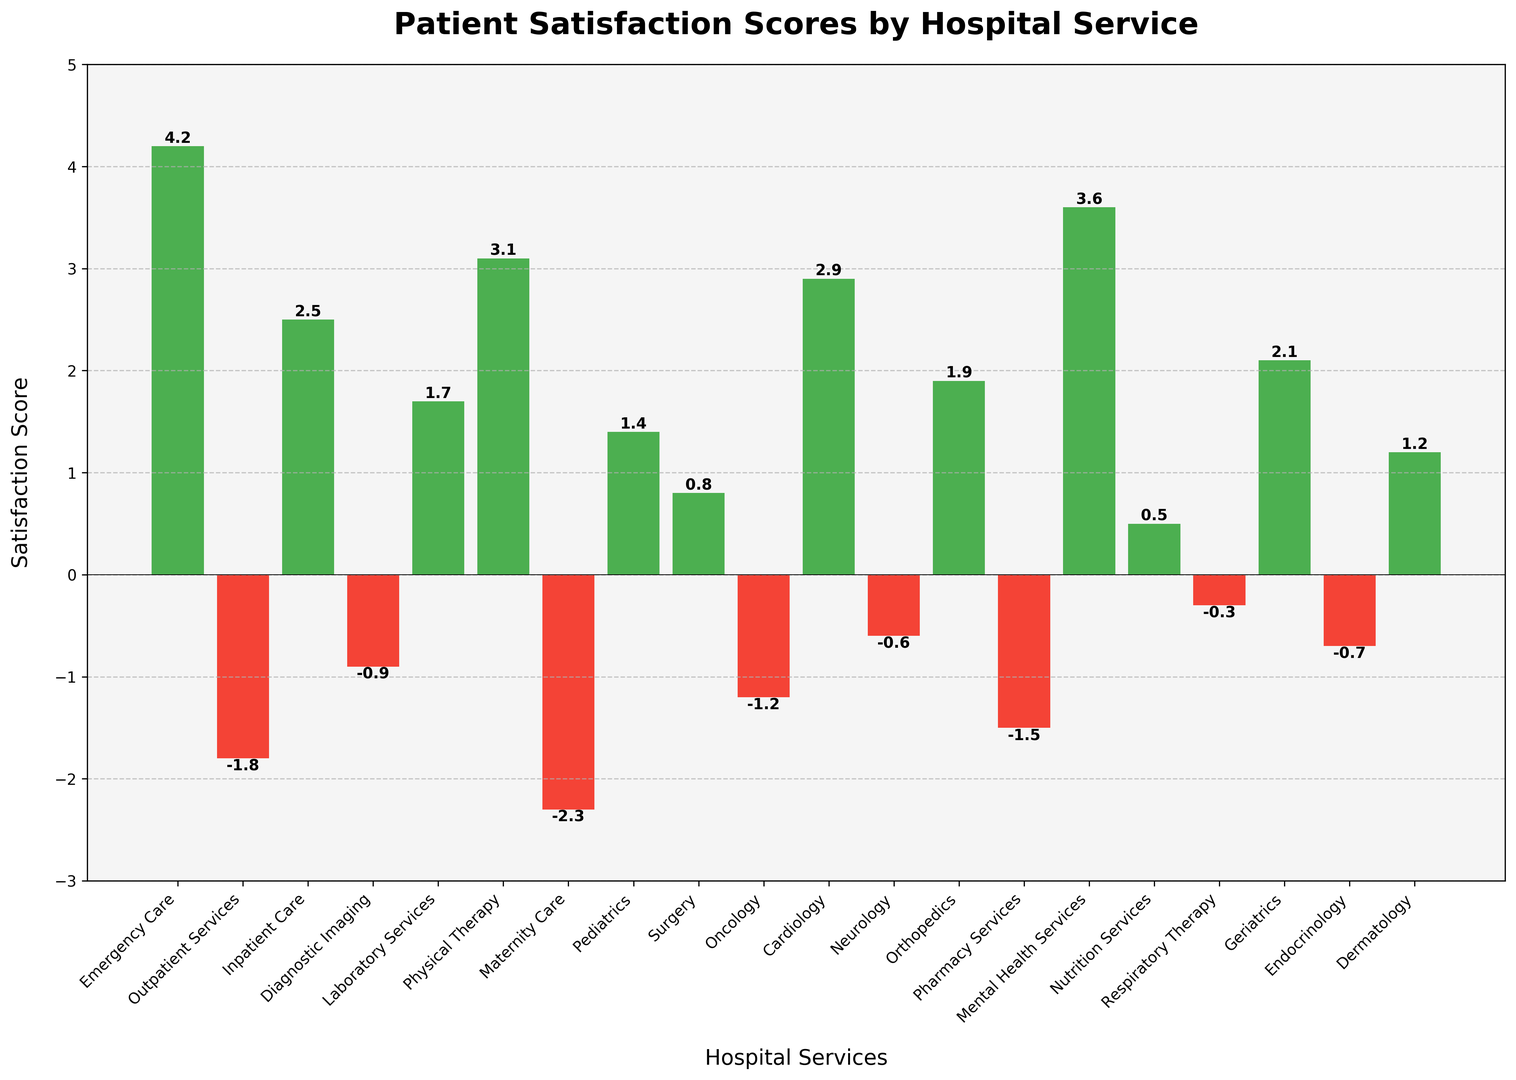What hospital services have negative patient satisfaction scores? To identify the services with negative patient satisfaction scores, look for bars that fall below the horizontal axis (y = 0). These bars are colored red.
Answer: Outpatient Services, Diagnostic Imaging, Maternity Care, Oncology, Pharmacy Services, Neurology, Respiratory Therapy, Endocrinology What is the highest patient satisfaction score, and which service does it belong to? Locate the tallest green bar in the chart, as green indicates positive scores. Read the value at the top of this bar and check the corresponding service on the x-axis.
Answer: Emergency Care, 4.2 Which hospital service has the lowest patient satisfaction score, and what is that score? Identify the shortest bar that falls below the x-axis (red bars). Read the value at the tip of this bar and the corresponding service.
Answer: Maternity Care, -2.3 What is the difference in satisfaction scores between Emergency Care and Maternity Care? Find the satisfaction scores of Emergency Care (4.2) and Maternity Care (-2.3). Subtract the latter from the former: 4.2 - (-2.3) = 4.2 + 2.3
Answer: 6.5 Compare satisfaction scores: Is the score for Physical Therapy higher or lower than that for Cardiology? Locate the bars for Physical Therapy (3.1) and Cardiology (2.9). Compare their heights: 3.1 is taller than 2.9.
Answer: Higher Which three services have scores closest to zero, whether positive or negative? Look for bars that are closest to the horizontal axis, both above and below. Those should have satisfaction scores close to zero.
Answer: Nutrition Services (0.5), Surgery (0.8), Respiratory Therapy (-0.3) What is the average satisfaction score of Inpatient Care and Pediatrics? Add the satisfaction scores of Inpatient Care (2.5) and Pediatrics (1.4), then divide by 2: (2.5 + 1.4) / 2
Answer: 1.95 By how many points does the satisfaction score of Laboratory Services exceed that of Diagnostic Imaging? Subtract the score of Diagnostic Imaging (-0.9) from that of Laboratory Services (1.7): 1.7 - (-0.9) = 1.7 + 0.9
Answer: 2.6 Are there more hospital services with positive or negative satisfaction scores? Count the number of green bars (positive scores) and the number of red bars (negative scores). Compare these counts.
Answer: Positive services: 12, Negative services: 8 Which service has a score of 3.6, and what color is the corresponding bar? Locate the bar labeled 3.6 and identify its color (green for positive). Find the corresponding service on the x-axis.
Answer: Mental Health Services, green 